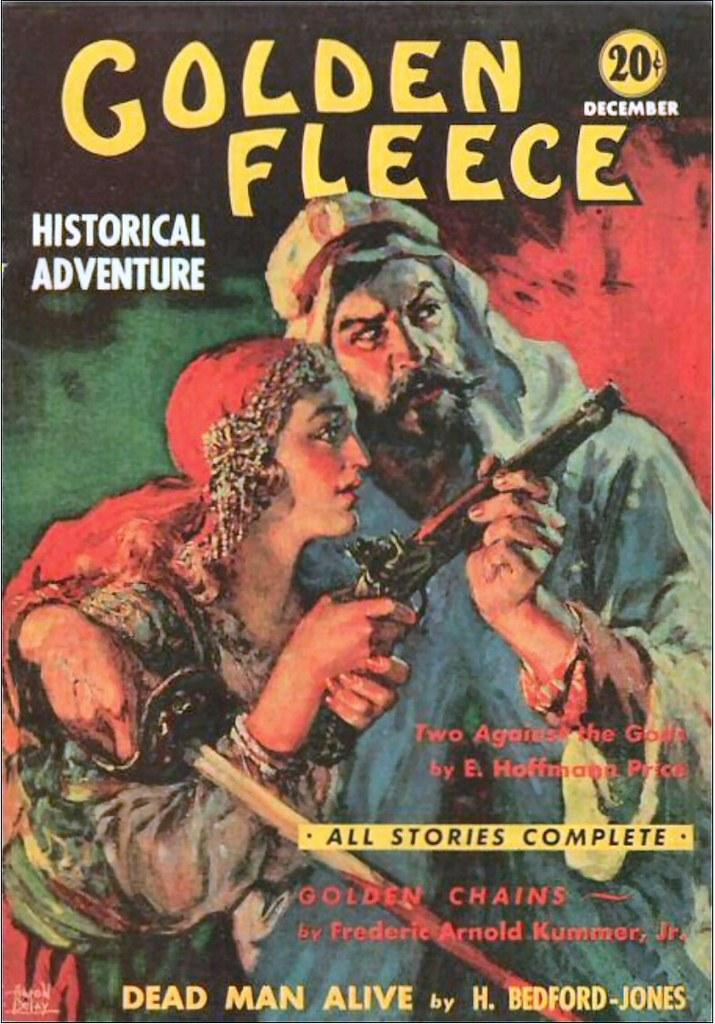What is featured on the poster in the image? There is a poster with writing on it, and it contains a picture of two people holding a gun. What type of lock is depicted on the canvas in the image? There is no lock or canvas present in the image; it features a poster with writing and a picture of two people holding a gun. What musical instrument can be seen being played by the people in the image? There is no musical instrument present in the image; the people are holding a gun. 